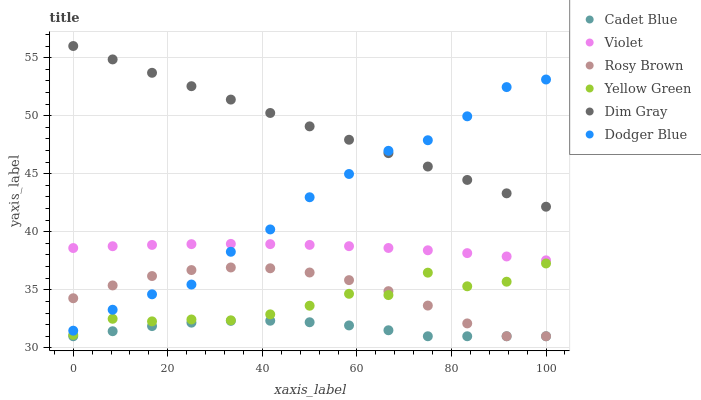Does Cadet Blue have the minimum area under the curve?
Answer yes or no. Yes. Does Dim Gray have the maximum area under the curve?
Answer yes or no. Yes. Does Yellow Green have the minimum area under the curve?
Answer yes or no. No. Does Yellow Green have the maximum area under the curve?
Answer yes or no. No. Is Dim Gray the smoothest?
Answer yes or no. Yes. Is Yellow Green the roughest?
Answer yes or no. Yes. Is Rosy Brown the smoothest?
Answer yes or no. No. Is Rosy Brown the roughest?
Answer yes or no. No. Does Cadet Blue have the lowest value?
Answer yes or no. Yes. Does Yellow Green have the lowest value?
Answer yes or no. No. Does Dim Gray have the highest value?
Answer yes or no. Yes. Does Yellow Green have the highest value?
Answer yes or no. No. Is Cadet Blue less than Dodger Blue?
Answer yes or no. Yes. Is Dim Gray greater than Rosy Brown?
Answer yes or no. Yes. Does Rosy Brown intersect Dodger Blue?
Answer yes or no. Yes. Is Rosy Brown less than Dodger Blue?
Answer yes or no. No. Is Rosy Brown greater than Dodger Blue?
Answer yes or no. No. Does Cadet Blue intersect Dodger Blue?
Answer yes or no. No. 